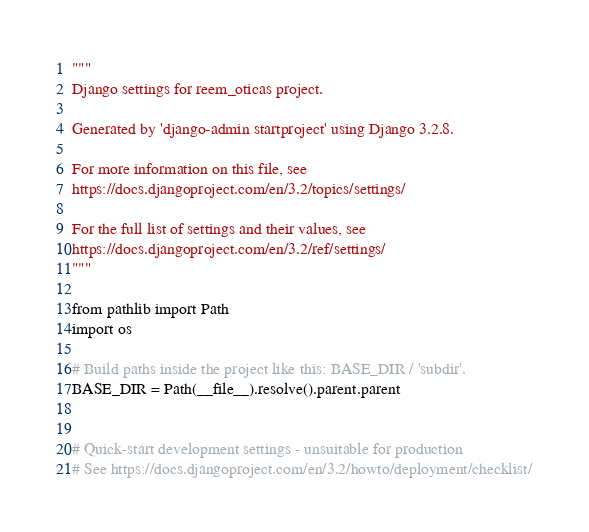<code> <loc_0><loc_0><loc_500><loc_500><_Python_>"""
Django settings for reem_oticas project.

Generated by 'django-admin startproject' using Django 3.2.8.

For more information on this file, see
https://docs.djangoproject.com/en/3.2/topics/settings/

For the full list of settings and their values, see
https://docs.djangoproject.com/en/3.2/ref/settings/
"""

from pathlib import Path
import os

# Build paths inside the project like this: BASE_DIR / 'subdir'.
BASE_DIR = Path(__file__).resolve().parent.parent


# Quick-start development settings - unsuitable for production
# See https://docs.djangoproject.com/en/3.2/howto/deployment/checklist/
</code> 